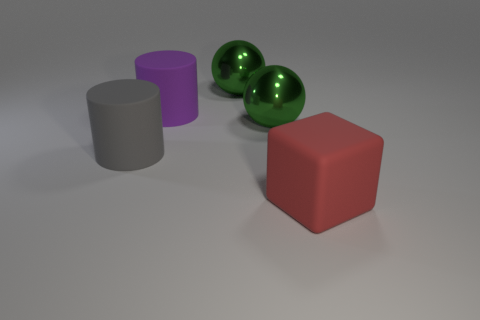Add 1 red matte objects. How many objects exist? 6 Subtract all cylinders. How many objects are left? 3 Add 3 big metal things. How many big metal things exist? 5 Subtract 0 yellow balls. How many objects are left? 5 Subtract all green spheres. Subtract all green shiny things. How many objects are left? 1 Add 4 large green objects. How many large green objects are left? 6 